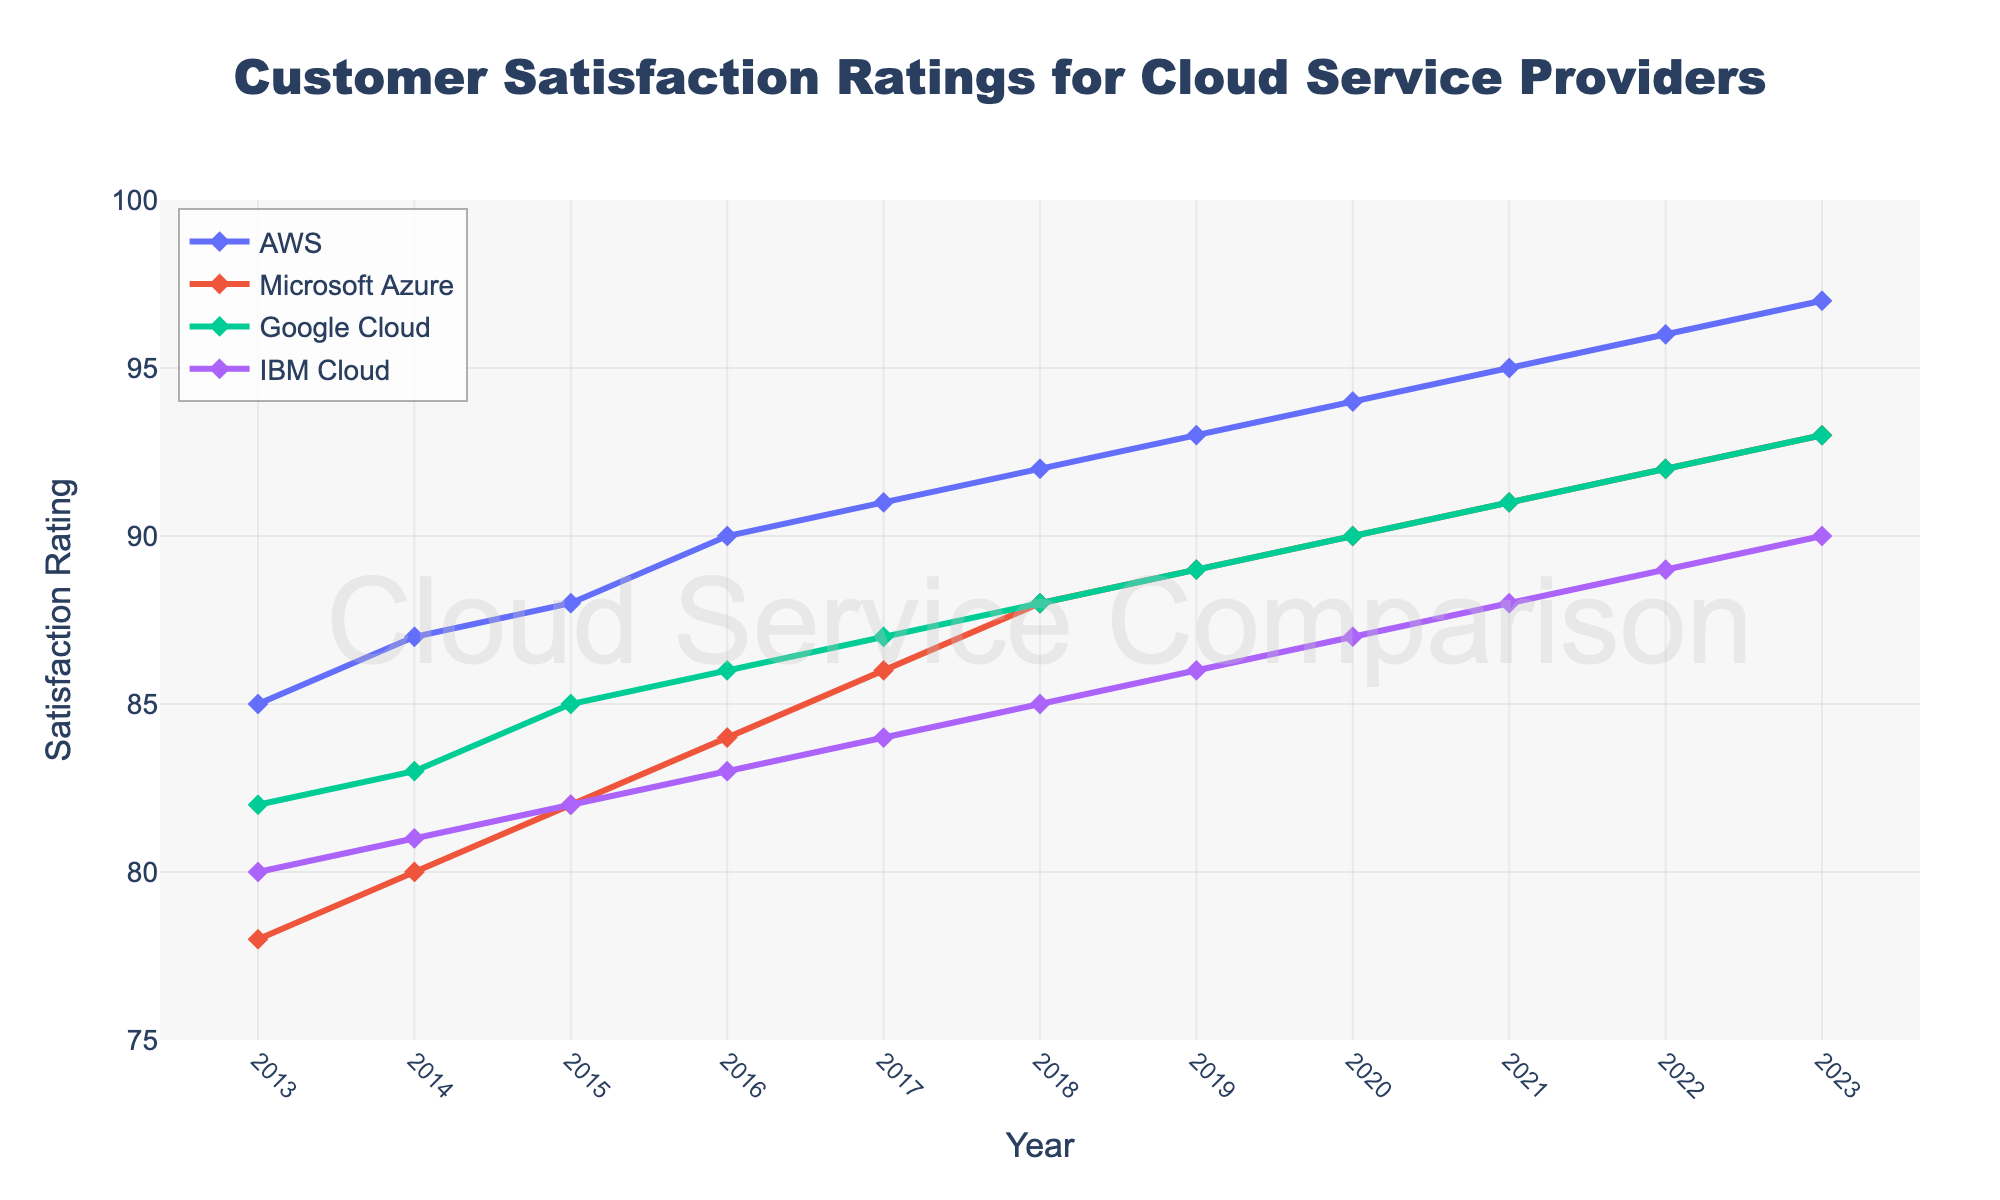What year did AWS first achieve a satisfaction rating of 90? To find the year, locate the line for AWS and find the point where it crosses the 90 mark on the y-axis.
Answer: 2016 In which year did Google Cloud's satisfaction rating equal Microsoft's Azure rating? Locate the lines for Google Cloud and Microsoft Azure and look for the year where both have the same rating value.
Answer: 2023 Between 2018 and 2020, which cloud service provider showed the highest increase in customer satisfaction ratings? Calculate the difference in satisfaction ratings from 2018 to 2020 for each provider and compare them. AWS: 94-92 = 2, Microsoft Azure: 90-88 = 2, Google Cloud: 90-88 = 2, IBM Cloud: 87-85 = 2. All showed the same increase.
Answer: All providers What is the average customer satisfaction rating for IBM Cloud from 2013 to 2023? Sum the satisfaction ratings for IBM Cloud from 2013 to 2023 and then divide by the number of years (11). (80+81+82+83+84+85+86+87+88+89+90)/11 = 85
Answer: 85 Which cloud service provider had the lowest satisfaction rating in 2021? Identify the satisfaction ratings for all providers in 2021 and find the lowest value.
Answer: IBM Cloud How many times did the satisfaction rating for AWS increase by exactly 1 point from one year to the next? Examine the AWS line and count the instances where the rating increased by exactly 1 point from one year to the next.
Answer: 6 Between 2013 and 2023, which cloud service provider had the most significant overall increase in customer satisfaction ratings? Calculate the increase in satisfaction ratings from 2013 to 2023 for each provider and compare them. AWS: 97-85 = 12, Microsoft Azure: 93-78 = 15, Google Cloud: 93-82 = 11, IBM Cloud: 90-80 = 10.
Answer: Microsoft Azure For how many consecutive years did Google Cloud's satisfaction rating increase each year? Follow the Google Cloud line and count the number of consecutive years where the rating increased.
Answer: 10 In 2023, which cloud service provider had the second-highest satisfaction rating? Identify the satisfaction ratings for all providers in 2023 and determine the second-highest value.
Answer: Microsoft Azure 